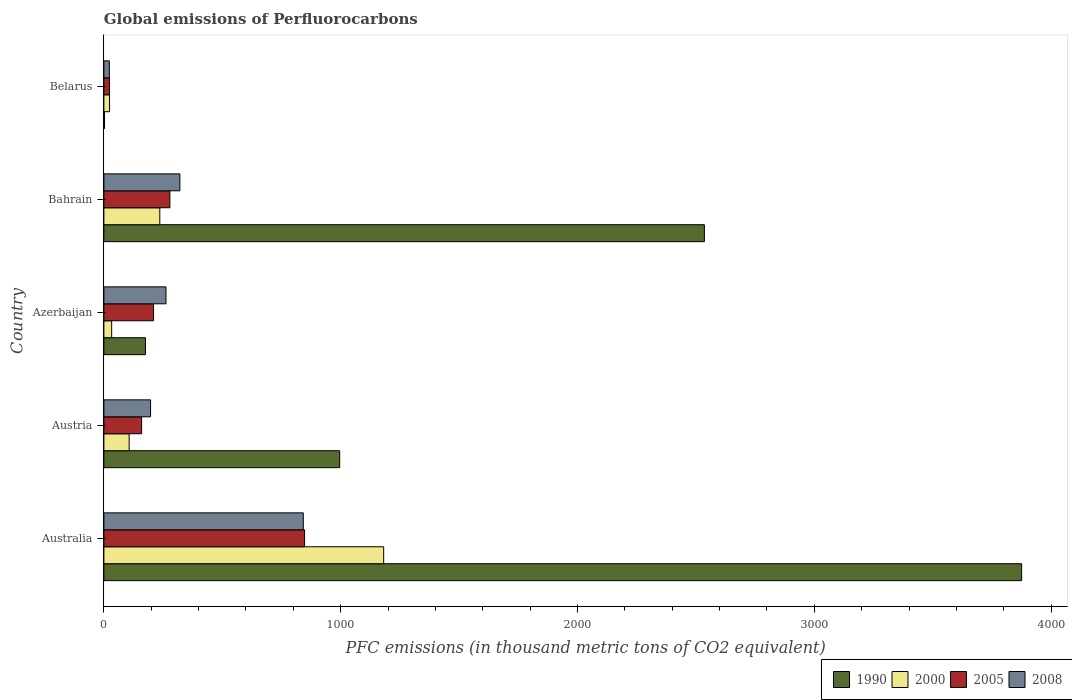Are the number of bars per tick equal to the number of legend labels?
Provide a succinct answer. Yes. In how many cases, is the number of bars for a given country not equal to the number of legend labels?
Make the answer very short. 0. What is the global emissions of Perfluorocarbons in 2005 in Austria?
Ensure brevity in your answer.  159.3. Across all countries, what is the maximum global emissions of Perfluorocarbons in 2008?
Your answer should be very brief. 842. Across all countries, what is the minimum global emissions of Perfluorocarbons in 2005?
Ensure brevity in your answer.  23.4. In which country was the global emissions of Perfluorocarbons in 2005 maximum?
Your answer should be very brief. Australia. In which country was the global emissions of Perfluorocarbons in 1990 minimum?
Keep it short and to the point. Belarus. What is the total global emissions of Perfluorocarbons in 2000 in the graph?
Offer a terse response. 1580.9. What is the difference between the global emissions of Perfluorocarbons in 2005 in Austria and that in Bahrain?
Offer a terse response. -119.3. What is the difference between the global emissions of Perfluorocarbons in 1990 in Bahrain and the global emissions of Perfluorocarbons in 2008 in Azerbaijan?
Make the answer very short. 2273.5. What is the average global emissions of Perfluorocarbons in 1990 per country?
Offer a very short reply. 1516.96. What is the difference between the global emissions of Perfluorocarbons in 2008 and global emissions of Perfluorocarbons in 2005 in Azerbaijan?
Provide a succinct answer. 52.5. What is the ratio of the global emissions of Perfluorocarbons in 2008 in Austria to that in Bahrain?
Your answer should be compact. 0.61. Is the difference between the global emissions of Perfluorocarbons in 2008 in Austria and Bahrain greater than the difference between the global emissions of Perfluorocarbons in 2005 in Austria and Bahrain?
Give a very brief answer. No. What is the difference between the highest and the second highest global emissions of Perfluorocarbons in 2008?
Make the answer very short. 521.1. What is the difference between the highest and the lowest global emissions of Perfluorocarbons in 2000?
Offer a very short reply. 1157.5. In how many countries, is the global emissions of Perfluorocarbons in 2005 greater than the average global emissions of Perfluorocarbons in 2005 taken over all countries?
Keep it short and to the point. 1. Is the sum of the global emissions of Perfluorocarbons in 1990 in Austria and Belarus greater than the maximum global emissions of Perfluorocarbons in 2005 across all countries?
Offer a terse response. Yes. Is it the case that in every country, the sum of the global emissions of Perfluorocarbons in 2008 and global emissions of Perfluorocarbons in 1990 is greater than the sum of global emissions of Perfluorocarbons in 2000 and global emissions of Perfluorocarbons in 2005?
Provide a short and direct response. No. What does the 2nd bar from the bottom in Austria represents?
Make the answer very short. 2000. What is the difference between two consecutive major ticks on the X-axis?
Make the answer very short. 1000. Where does the legend appear in the graph?
Ensure brevity in your answer.  Bottom right. How many legend labels are there?
Your answer should be very brief. 4. How are the legend labels stacked?
Keep it short and to the point. Horizontal. What is the title of the graph?
Offer a terse response. Global emissions of Perfluorocarbons. What is the label or title of the X-axis?
Your answer should be compact. PFC emissions (in thousand metric tons of CO2 equivalent). What is the label or title of the Y-axis?
Offer a very short reply. Country. What is the PFC emissions (in thousand metric tons of CO2 equivalent) of 1990 in Australia?
Give a very brief answer. 3875.2. What is the PFC emissions (in thousand metric tons of CO2 equivalent) in 2000 in Australia?
Offer a very short reply. 1181.4. What is the PFC emissions (in thousand metric tons of CO2 equivalent) of 2005 in Australia?
Your answer should be compact. 847.4. What is the PFC emissions (in thousand metric tons of CO2 equivalent) in 2008 in Australia?
Ensure brevity in your answer.  842. What is the PFC emissions (in thousand metric tons of CO2 equivalent) in 1990 in Austria?
Keep it short and to the point. 995.7. What is the PFC emissions (in thousand metric tons of CO2 equivalent) of 2000 in Austria?
Provide a short and direct response. 106.7. What is the PFC emissions (in thousand metric tons of CO2 equivalent) in 2005 in Austria?
Keep it short and to the point. 159.3. What is the PFC emissions (in thousand metric tons of CO2 equivalent) of 2008 in Austria?
Your response must be concise. 197.1. What is the PFC emissions (in thousand metric tons of CO2 equivalent) of 1990 in Azerbaijan?
Provide a succinct answer. 175.6. What is the PFC emissions (in thousand metric tons of CO2 equivalent) of 2000 in Azerbaijan?
Make the answer very short. 32.8. What is the PFC emissions (in thousand metric tons of CO2 equivalent) in 2005 in Azerbaijan?
Offer a terse response. 209.7. What is the PFC emissions (in thousand metric tons of CO2 equivalent) of 2008 in Azerbaijan?
Your answer should be compact. 262.2. What is the PFC emissions (in thousand metric tons of CO2 equivalent) of 1990 in Bahrain?
Your answer should be very brief. 2535.7. What is the PFC emissions (in thousand metric tons of CO2 equivalent) in 2000 in Bahrain?
Provide a short and direct response. 236.1. What is the PFC emissions (in thousand metric tons of CO2 equivalent) of 2005 in Bahrain?
Give a very brief answer. 278.6. What is the PFC emissions (in thousand metric tons of CO2 equivalent) of 2008 in Bahrain?
Keep it short and to the point. 320.9. What is the PFC emissions (in thousand metric tons of CO2 equivalent) in 1990 in Belarus?
Your answer should be very brief. 2.6. What is the PFC emissions (in thousand metric tons of CO2 equivalent) in 2000 in Belarus?
Your answer should be compact. 23.9. What is the PFC emissions (in thousand metric tons of CO2 equivalent) of 2005 in Belarus?
Your answer should be compact. 23.4. What is the PFC emissions (in thousand metric tons of CO2 equivalent) of 2008 in Belarus?
Make the answer very short. 23.1. Across all countries, what is the maximum PFC emissions (in thousand metric tons of CO2 equivalent) in 1990?
Your response must be concise. 3875.2. Across all countries, what is the maximum PFC emissions (in thousand metric tons of CO2 equivalent) in 2000?
Ensure brevity in your answer.  1181.4. Across all countries, what is the maximum PFC emissions (in thousand metric tons of CO2 equivalent) in 2005?
Provide a short and direct response. 847.4. Across all countries, what is the maximum PFC emissions (in thousand metric tons of CO2 equivalent) of 2008?
Ensure brevity in your answer.  842. Across all countries, what is the minimum PFC emissions (in thousand metric tons of CO2 equivalent) in 2000?
Ensure brevity in your answer.  23.9. Across all countries, what is the minimum PFC emissions (in thousand metric tons of CO2 equivalent) in 2005?
Your response must be concise. 23.4. Across all countries, what is the minimum PFC emissions (in thousand metric tons of CO2 equivalent) of 2008?
Ensure brevity in your answer.  23.1. What is the total PFC emissions (in thousand metric tons of CO2 equivalent) of 1990 in the graph?
Ensure brevity in your answer.  7584.8. What is the total PFC emissions (in thousand metric tons of CO2 equivalent) in 2000 in the graph?
Offer a terse response. 1580.9. What is the total PFC emissions (in thousand metric tons of CO2 equivalent) of 2005 in the graph?
Provide a short and direct response. 1518.4. What is the total PFC emissions (in thousand metric tons of CO2 equivalent) of 2008 in the graph?
Ensure brevity in your answer.  1645.3. What is the difference between the PFC emissions (in thousand metric tons of CO2 equivalent) in 1990 in Australia and that in Austria?
Your answer should be very brief. 2879.5. What is the difference between the PFC emissions (in thousand metric tons of CO2 equivalent) in 2000 in Australia and that in Austria?
Your answer should be compact. 1074.7. What is the difference between the PFC emissions (in thousand metric tons of CO2 equivalent) in 2005 in Australia and that in Austria?
Provide a short and direct response. 688.1. What is the difference between the PFC emissions (in thousand metric tons of CO2 equivalent) of 2008 in Australia and that in Austria?
Provide a short and direct response. 644.9. What is the difference between the PFC emissions (in thousand metric tons of CO2 equivalent) in 1990 in Australia and that in Azerbaijan?
Your answer should be very brief. 3699.6. What is the difference between the PFC emissions (in thousand metric tons of CO2 equivalent) of 2000 in Australia and that in Azerbaijan?
Provide a short and direct response. 1148.6. What is the difference between the PFC emissions (in thousand metric tons of CO2 equivalent) of 2005 in Australia and that in Azerbaijan?
Your answer should be compact. 637.7. What is the difference between the PFC emissions (in thousand metric tons of CO2 equivalent) in 2008 in Australia and that in Azerbaijan?
Ensure brevity in your answer.  579.8. What is the difference between the PFC emissions (in thousand metric tons of CO2 equivalent) in 1990 in Australia and that in Bahrain?
Give a very brief answer. 1339.5. What is the difference between the PFC emissions (in thousand metric tons of CO2 equivalent) of 2000 in Australia and that in Bahrain?
Provide a short and direct response. 945.3. What is the difference between the PFC emissions (in thousand metric tons of CO2 equivalent) of 2005 in Australia and that in Bahrain?
Provide a short and direct response. 568.8. What is the difference between the PFC emissions (in thousand metric tons of CO2 equivalent) in 2008 in Australia and that in Bahrain?
Your response must be concise. 521.1. What is the difference between the PFC emissions (in thousand metric tons of CO2 equivalent) of 1990 in Australia and that in Belarus?
Your answer should be compact. 3872.6. What is the difference between the PFC emissions (in thousand metric tons of CO2 equivalent) of 2000 in Australia and that in Belarus?
Offer a very short reply. 1157.5. What is the difference between the PFC emissions (in thousand metric tons of CO2 equivalent) of 2005 in Australia and that in Belarus?
Provide a succinct answer. 824. What is the difference between the PFC emissions (in thousand metric tons of CO2 equivalent) in 2008 in Australia and that in Belarus?
Give a very brief answer. 818.9. What is the difference between the PFC emissions (in thousand metric tons of CO2 equivalent) in 1990 in Austria and that in Azerbaijan?
Your answer should be very brief. 820.1. What is the difference between the PFC emissions (in thousand metric tons of CO2 equivalent) in 2000 in Austria and that in Azerbaijan?
Offer a very short reply. 73.9. What is the difference between the PFC emissions (in thousand metric tons of CO2 equivalent) in 2005 in Austria and that in Azerbaijan?
Offer a terse response. -50.4. What is the difference between the PFC emissions (in thousand metric tons of CO2 equivalent) in 2008 in Austria and that in Azerbaijan?
Your answer should be very brief. -65.1. What is the difference between the PFC emissions (in thousand metric tons of CO2 equivalent) in 1990 in Austria and that in Bahrain?
Provide a short and direct response. -1540. What is the difference between the PFC emissions (in thousand metric tons of CO2 equivalent) in 2000 in Austria and that in Bahrain?
Your response must be concise. -129.4. What is the difference between the PFC emissions (in thousand metric tons of CO2 equivalent) in 2005 in Austria and that in Bahrain?
Your response must be concise. -119.3. What is the difference between the PFC emissions (in thousand metric tons of CO2 equivalent) of 2008 in Austria and that in Bahrain?
Provide a succinct answer. -123.8. What is the difference between the PFC emissions (in thousand metric tons of CO2 equivalent) of 1990 in Austria and that in Belarus?
Offer a very short reply. 993.1. What is the difference between the PFC emissions (in thousand metric tons of CO2 equivalent) in 2000 in Austria and that in Belarus?
Provide a short and direct response. 82.8. What is the difference between the PFC emissions (in thousand metric tons of CO2 equivalent) in 2005 in Austria and that in Belarus?
Your answer should be very brief. 135.9. What is the difference between the PFC emissions (in thousand metric tons of CO2 equivalent) in 2008 in Austria and that in Belarus?
Provide a short and direct response. 174. What is the difference between the PFC emissions (in thousand metric tons of CO2 equivalent) in 1990 in Azerbaijan and that in Bahrain?
Offer a very short reply. -2360.1. What is the difference between the PFC emissions (in thousand metric tons of CO2 equivalent) of 2000 in Azerbaijan and that in Bahrain?
Provide a succinct answer. -203.3. What is the difference between the PFC emissions (in thousand metric tons of CO2 equivalent) in 2005 in Azerbaijan and that in Bahrain?
Your answer should be compact. -68.9. What is the difference between the PFC emissions (in thousand metric tons of CO2 equivalent) in 2008 in Azerbaijan and that in Bahrain?
Make the answer very short. -58.7. What is the difference between the PFC emissions (in thousand metric tons of CO2 equivalent) in 1990 in Azerbaijan and that in Belarus?
Your answer should be very brief. 173. What is the difference between the PFC emissions (in thousand metric tons of CO2 equivalent) of 2000 in Azerbaijan and that in Belarus?
Provide a short and direct response. 8.9. What is the difference between the PFC emissions (in thousand metric tons of CO2 equivalent) of 2005 in Azerbaijan and that in Belarus?
Ensure brevity in your answer.  186.3. What is the difference between the PFC emissions (in thousand metric tons of CO2 equivalent) in 2008 in Azerbaijan and that in Belarus?
Keep it short and to the point. 239.1. What is the difference between the PFC emissions (in thousand metric tons of CO2 equivalent) of 1990 in Bahrain and that in Belarus?
Keep it short and to the point. 2533.1. What is the difference between the PFC emissions (in thousand metric tons of CO2 equivalent) in 2000 in Bahrain and that in Belarus?
Keep it short and to the point. 212.2. What is the difference between the PFC emissions (in thousand metric tons of CO2 equivalent) in 2005 in Bahrain and that in Belarus?
Offer a very short reply. 255.2. What is the difference between the PFC emissions (in thousand metric tons of CO2 equivalent) in 2008 in Bahrain and that in Belarus?
Provide a succinct answer. 297.8. What is the difference between the PFC emissions (in thousand metric tons of CO2 equivalent) of 1990 in Australia and the PFC emissions (in thousand metric tons of CO2 equivalent) of 2000 in Austria?
Make the answer very short. 3768.5. What is the difference between the PFC emissions (in thousand metric tons of CO2 equivalent) of 1990 in Australia and the PFC emissions (in thousand metric tons of CO2 equivalent) of 2005 in Austria?
Provide a succinct answer. 3715.9. What is the difference between the PFC emissions (in thousand metric tons of CO2 equivalent) in 1990 in Australia and the PFC emissions (in thousand metric tons of CO2 equivalent) in 2008 in Austria?
Make the answer very short. 3678.1. What is the difference between the PFC emissions (in thousand metric tons of CO2 equivalent) of 2000 in Australia and the PFC emissions (in thousand metric tons of CO2 equivalent) of 2005 in Austria?
Give a very brief answer. 1022.1. What is the difference between the PFC emissions (in thousand metric tons of CO2 equivalent) of 2000 in Australia and the PFC emissions (in thousand metric tons of CO2 equivalent) of 2008 in Austria?
Offer a very short reply. 984.3. What is the difference between the PFC emissions (in thousand metric tons of CO2 equivalent) in 2005 in Australia and the PFC emissions (in thousand metric tons of CO2 equivalent) in 2008 in Austria?
Provide a short and direct response. 650.3. What is the difference between the PFC emissions (in thousand metric tons of CO2 equivalent) in 1990 in Australia and the PFC emissions (in thousand metric tons of CO2 equivalent) in 2000 in Azerbaijan?
Give a very brief answer. 3842.4. What is the difference between the PFC emissions (in thousand metric tons of CO2 equivalent) in 1990 in Australia and the PFC emissions (in thousand metric tons of CO2 equivalent) in 2005 in Azerbaijan?
Ensure brevity in your answer.  3665.5. What is the difference between the PFC emissions (in thousand metric tons of CO2 equivalent) of 1990 in Australia and the PFC emissions (in thousand metric tons of CO2 equivalent) of 2008 in Azerbaijan?
Offer a very short reply. 3613. What is the difference between the PFC emissions (in thousand metric tons of CO2 equivalent) in 2000 in Australia and the PFC emissions (in thousand metric tons of CO2 equivalent) in 2005 in Azerbaijan?
Provide a short and direct response. 971.7. What is the difference between the PFC emissions (in thousand metric tons of CO2 equivalent) of 2000 in Australia and the PFC emissions (in thousand metric tons of CO2 equivalent) of 2008 in Azerbaijan?
Offer a terse response. 919.2. What is the difference between the PFC emissions (in thousand metric tons of CO2 equivalent) of 2005 in Australia and the PFC emissions (in thousand metric tons of CO2 equivalent) of 2008 in Azerbaijan?
Provide a short and direct response. 585.2. What is the difference between the PFC emissions (in thousand metric tons of CO2 equivalent) of 1990 in Australia and the PFC emissions (in thousand metric tons of CO2 equivalent) of 2000 in Bahrain?
Offer a very short reply. 3639.1. What is the difference between the PFC emissions (in thousand metric tons of CO2 equivalent) in 1990 in Australia and the PFC emissions (in thousand metric tons of CO2 equivalent) in 2005 in Bahrain?
Provide a short and direct response. 3596.6. What is the difference between the PFC emissions (in thousand metric tons of CO2 equivalent) in 1990 in Australia and the PFC emissions (in thousand metric tons of CO2 equivalent) in 2008 in Bahrain?
Provide a short and direct response. 3554.3. What is the difference between the PFC emissions (in thousand metric tons of CO2 equivalent) of 2000 in Australia and the PFC emissions (in thousand metric tons of CO2 equivalent) of 2005 in Bahrain?
Give a very brief answer. 902.8. What is the difference between the PFC emissions (in thousand metric tons of CO2 equivalent) in 2000 in Australia and the PFC emissions (in thousand metric tons of CO2 equivalent) in 2008 in Bahrain?
Keep it short and to the point. 860.5. What is the difference between the PFC emissions (in thousand metric tons of CO2 equivalent) in 2005 in Australia and the PFC emissions (in thousand metric tons of CO2 equivalent) in 2008 in Bahrain?
Make the answer very short. 526.5. What is the difference between the PFC emissions (in thousand metric tons of CO2 equivalent) of 1990 in Australia and the PFC emissions (in thousand metric tons of CO2 equivalent) of 2000 in Belarus?
Offer a terse response. 3851.3. What is the difference between the PFC emissions (in thousand metric tons of CO2 equivalent) in 1990 in Australia and the PFC emissions (in thousand metric tons of CO2 equivalent) in 2005 in Belarus?
Your answer should be compact. 3851.8. What is the difference between the PFC emissions (in thousand metric tons of CO2 equivalent) of 1990 in Australia and the PFC emissions (in thousand metric tons of CO2 equivalent) of 2008 in Belarus?
Offer a terse response. 3852.1. What is the difference between the PFC emissions (in thousand metric tons of CO2 equivalent) in 2000 in Australia and the PFC emissions (in thousand metric tons of CO2 equivalent) in 2005 in Belarus?
Your answer should be very brief. 1158. What is the difference between the PFC emissions (in thousand metric tons of CO2 equivalent) in 2000 in Australia and the PFC emissions (in thousand metric tons of CO2 equivalent) in 2008 in Belarus?
Offer a terse response. 1158.3. What is the difference between the PFC emissions (in thousand metric tons of CO2 equivalent) of 2005 in Australia and the PFC emissions (in thousand metric tons of CO2 equivalent) of 2008 in Belarus?
Give a very brief answer. 824.3. What is the difference between the PFC emissions (in thousand metric tons of CO2 equivalent) of 1990 in Austria and the PFC emissions (in thousand metric tons of CO2 equivalent) of 2000 in Azerbaijan?
Provide a succinct answer. 962.9. What is the difference between the PFC emissions (in thousand metric tons of CO2 equivalent) in 1990 in Austria and the PFC emissions (in thousand metric tons of CO2 equivalent) in 2005 in Azerbaijan?
Make the answer very short. 786. What is the difference between the PFC emissions (in thousand metric tons of CO2 equivalent) of 1990 in Austria and the PFC emissions (in thousand metric tons of CO2 equivalent) of 2008 in Azerbaijan?
Make the answer very short. 733.5. What is the difference between the PFC emissions (in thousand metric tons of CO2 equivalent) of 2000 in Austria and the PFC emissions (in thousand metric tons of CO2 equivalent) of 2005 in Azerbaijan?
Ensure brevity in your answer.  -103. What is the difference between the PFC emissions (in thousand metric tons of CO2 equivalent) in 2000 in Austria and the PFC emissions (in thousand metric tons of CO2 equivalent) in 2008 in Azerbaijan?
Your answer should be compact. -155.5. What is the difference between the PFC emissions (in thousand metric tons of CO2 equivalent) of 2005 in Austria and the PFC emissions (in thousand metric tons of CO2 equivalent) of 2008 in Azerbaijan?
Your answer should be very brief. -102.9. What is the difference between the PFC emissions (in thousand metric tons of CO2 equivalent) of 1990 in Austria and the PFC emissions (in thousand metric tons of CO2 equivalent) of 2000 in Bahrain?
Ensure brevity in your answer.  759.6. What is the difference between the PFC emissions (in thousand metric tons of CO2 equivalent) of 1990 in Austria and the PFC emissions (in thousand metric tons of CO2 equivalent) of 2005 in Bahrain?
Your answer should be very brief. 717.1. What is the difference between the PFC emissions (in thousand metric tons of CO2 equivalent) of 1990 in Austria and the PFC emissions (in thousand metric tons of CO2 equivalent) of 2008 in Bahrain?
Provide a short and direct response. 674.8. What is the difference between the PFC emissions (in thousand metric tons of CO2 equivalent) in 2000 in Austria and the PFC emissions (in thousand metric tons of CO2 equivalent) in 2005 in Bahrain?
Offer a very short reply. -171.9. What is the difference between the PFC emissions (in thousand metric tons of CO2 equivalent) in 2000 in Austria and the PFC emissions (in thousand metric tons of CO2 equivalent) in 2008 in Bahrain?
Your answer should be very brief. -214.2. What is the difference between the PFC emissions (in thousand metric tons of CO2 equivalent) in 2005 in Austria and the PFC emissions (in thousand metric tons of CO2 equivalent) in 2008 in Bahrain?
Ensure brevity in your answer.  -161.6. What is the difference between the PFC emissions (in thousand metric tons of CO2 equivalent) of 1990 in Austria and the PFC emissions (in thousand metric tons of CO2 equivalent) of 2000 in Belarus?
Keep it short and to the point. 971.8. What is the difference between the PFC emissions (in thousand metric tons of CO2 equivalent) of 1990 in Austria and the PFC emissions (in thousand metric tons of CO2 equivalent) of 2005 in Belarus?
Ensure brevity in your answer.  972.3. What is the difference between the PFC emissions (in thousand metric tons of CO2 equivalent) of 1990 in Austria and the PFC emissions (in thousand metric tons of CO2 equivalent) of 2008 in Belarus?
Your response must be concise. 972.6. What is the difference between the PFC emissions (in thousand metric tons of CO2 equivalent) in 2000 in Austria and the PFC emissions (in thousand metric tons of CO2 equivalent) in 2005 in Belarus?
Offer a terse response. 83.3. What is the difference between the PFC emissions (in thousand metric tons of CO2 equivalent) in 2000 in Austria and the PFC emissions (in thousand metric tons of CO2 equivalent) in 2008 in Belarus?
Offer a very short reply. 83.6. What is the difference between the PFC emissions (in thousand metric tons of CO2 equivalent) of 2005 in Austria and the PFC emissions (in thousand metric tons of CO2 equivalent) of 2008 in Belarus?
Provide a succinct answer. 136.2. What is the difference between the PFC emissions (in thousand metric tons of CO2 equivalent) in 1990 in Azerbaijan and the PFC emissions (in thousand metric tons of CO2 equivalent) in 2000 in Bahrain?
Offer a terse response. -60.5. What is the difference between the PFC emissions (in thousand metric tons of CO2 equivalent) of 1990 in Azerbaijan and the PFC emissions (in thousand metric tons of CO2 equivalent) of 2005 in Bahrain?
Ensure brevity in your answer.  -103. What is the difference between the PFC emissions (in thousand metric tons of CO2 equivalent) in 1990 in Azerbaijan and the PFC emissions (in thousand metric tons of CO2 equivalent) in 2008 in Bahrain?
Provide a short and direct response. -145.3. What is the difference between the PFC emissions (in thousand metric tons of CO2 equivalent) in 2000 in Azerbaijan and the PFC emissions (in thousand metric tons of CO2 equivalent) in 2005 in Bahrain?
Make the answer very short. -245.8. What is the difference between the PFC emissions (in thousand metric tons of CO2 equivalent) in 2000 in Azerbaijan and the PFC emissions (in thousand metric tons of CO2 equivalent) in 2008 in Bahrain?
Your answer should be very brief. -288.1. What is the difference between the PFC emissions (in thousand metric tons of CO2 equivalent) in 2005 in Azerbaijan and the PFC emissions (in thousand metric tons of CO2 equivalent) in 2008 in Bahrain?
Your answer should be very brief. -111.2. What is the difference between the PFC emissions (in thousand metric tons of CO2 equivalent) of 1990 in Azerbaijan and the PFC emissions (in thousand metric tons of CO2 equivalent) of 2000 in Belarus?
Ensure brevity in your answer.  151.7. What is the difference between the PFC emissions (in thousand metric tons of CO2 equivalent) in 1990 in Azerbaijan and the PFC emissions (in thousand metric tons of CO2 equivalent) in 2005 in Belarus?
Give a very brief answer. 152.2. What is the difference between the PFC emissions (in thousand metric tons of CO2 equivalent) in 1990 in Azerbaijan and the PFC emissions (in thousand metric tons of CO2 equivalent) in 2008 in Belarus?
Make the answer very short. 152.5. What is the difference between the PFC emissions (in thousand metric tons of CO2 equivalent) in 2000 in Azerbaijan and the PFC emissions (in thousand metric tons of CO2 equivalent) in 2005 in Belarus?
Provide a short and direct response. 9.4. What is the difference between the PFC emissions (in thousand metric tons of CO2 equivalent) in 2000 in Azerbaijan and the PFC emissions (in thousand metric tons of CO2 equivalent) in 2008 in Belarus?
Give a very brief answer. 9.7. What is the difference between the PFC emissions (in thousand metric tons of CO2 equivalent) in 2005 in Azerbaijan and the PFC emissions (in thousand metric tons of CO2 equivalent) in 2008 in Belarus?
Make the answer very short. 186.6. What is the difference between the PFC emissions (in thousand metric tons of CO2 equivalent) of 1990 in Bahrain and the PFC emissions (in thousand metric tons of CO2 equivalent) of 2000 in Belarus?
Your response must be concise. 2511.8. What is the difference between the PFC emissions (in thousand metric tons of CO2 equivalent) in 1990 in Bahrain and the PFC emissions (in thousand metric tons of CO2 equivalent) in 2005 in Belarus?
Give a very brief answer. 2512.3. What is the difference between the PFC emissions (in thousand metric tons of CO2 equivalent) in 1990 in Bahrain and the PFC emissions (in thousand metric tons of CO2 equivalent) in 2008 in Belarus?
Ensure brevity in your answer.  2512.6. What is the difference between the PFC emissions (in thousand metric tons of CO2 equivalent) of 2000 in Bahrain and the PFC emissions (in thousand metric tons of CO2 equivalent) of 2005 in Belarus?
Your answer should be compact. 212.7. What is the difference between the PFC emissions (in thousand metric tons of CO2 equivalent) of 2000 in Bahrain and the PFC emissions (in thousand metric tons of CO2 equivalent) of 2008 in Belarus?
Provide a succinct answer. 213. What is the difference between the PFC emissions (in thousand metric tons of CO2 equivalent) of 2005 in Bahrain and the PFC emissions (in thousand metric tons of CO2 equivalent) of 2008 in Belarus?
Provide a short and direct response. 255.5. What is the average PFC emissions (in thousand metric tons of CO2 equivalent) in 1990 per country?
Your answer should be compact. 1516.96. What is the average PFC emissions (in thousand metric tons of CO2 equivalent) of 2000 per country?
Ensure brevity in your answer.  316.18. What is the average PFC emissions (in thousand metric tons of CO2 equivalent) in 2005 per country?
Make the answer very short. 303.68. What is the average PFC emissions (in thousand metric tons of CO2 equivalent) of 2008 per country?
Make the answer very short. 329.06. What is the difference between the PFC emissions (in thousand metric tons of CO2 equivalent) in 1990 and PFC emissions (in thousand metric tons of CO2 equivalent) in 2000 in Australia?
Your answer should be very brief. 2693.8. What is the difference between the PFC emissions (in thousand metric tons of CO2 equivalent) of 1990 and PFC emissions (in thousand metric tons of CO2 equivalent) of 2005 in Australia?
Your answer should be compact. 3027.8. What is the difference between the PFC emissions (in thousand metric tons of CO2 equivalent) of 1990 and PFC emissions (in thousand metric tons of CO2 equivalent) of 2008 in Australia?
Offer a terse response. 3033.2. What is the difference between the PFC emissions (in thousand metric tons of CO2 equivalent) in 2000 and PFC emissions (in thousand metric tons of CO2 equivalent) in 2005 in Australia?
Give a very brief answer. 334. What is the difference between the PFC emissions (in thousand metric tons of CO2 equivalent) of 2000 and PFC emissions (in thousand metric tons of CO2 equivalent) of 2008 in Australia?
Give a very brief answer. 339.4. What is the difference between the PFC emissions (in thousand metric tons of CO2 equivalent) of 2005 and PFC emissions (in thousand metric tons of CO2 equivalent) of 2008 in Australia?
Ensure brevity in your answer.  5.4. What is the difference between the PFC emissions (in thousand metric tons of CO2 equivalent) of 1990 and PFC emissions (in thousand metric tons of CO2 equivalent) of 2000 in Austria?
Make the answer very short. 889. What is the difference between the PFC emissions (in thousand metric tons of CO2 equivalent) in 1990 and PFC emissions (in thousand metric tons of CO2 equivalent) in 2005 in Austria?
Make the answer very short. 836.4. What is the difference between the PFC emissions (in thousand metric tons of CO2 equivalent) of 1990 and PFC emissions (in thousand metric tons of CO2 equivalent) of 2008 in Austria?
Offer a very short reply. 798.6. What is the difference between the PFC emissions (in thousand metric tons of CO2 equivalent) in 2000 and PFC emissions (in thousand metric tons of CO2 equivalent) in 2005 in Austria?
Keep it short and to the point. -52.6. What is the difference between the PFC emissions (in thousand metric tons of CO2 equivalent) of 2000 and PFC emissions (in thousand metric tons of CO2 equivalent) of 2008 in Austria?
Your response must be concise. -90.4. What is the difference between the PFC emissions (in thousand metric tons of CO2 equivalent) of 2005 and PFC emissions (in thousand metric tons of CO2 equivalent) of 2008 in Austria?
Ensure brevity in your answer.  -37.8. What is the difference between the PFC emissions (in thousand metric tons of CO2 equivalent) of 1990 and PFC emissions (in thousand metric tons of CO2 equivalent) of 2000 in Azerbaijan?
Make the answer very short. 142.8. What is the difference between the PFC emissions (in thousand metric tons of CO2 equivalent) of 1990 and PFC emissions (in thousand metric tons of CO2 equivalent) of 2005 in Azerbaijan?
Ensure brevity in your answer.  -34.1. What is the difference between the PFC emissions (in thousand metric tons of CO2 equivalent) of 1990 and PFC emissions (in thousand metric tons of CO2 equivalent) of 2008 in Azerbaijan?
Your answer should be very brief. -86.6. What is the difference between the PFC emissions (in thousand metric tons of CO2 equivalent) in 2000 and PFC emissions (in thousand metric tons of CO2 equivalent) in 2005 in Azerbaijan?
Your response must be concise. -176.9. What is the difference between the PFC emissions (in thousand metric tons of CO2 equivalent) of 2000 and PFC emissions (in thousand metric tons of CO2 equivalent) of 2008 in Azerbaijan?
Give a very brief answer. -229.4. What is the difference between the PFC emissions (in thousand metric tons of CO2 equivalent) in 2005 and PFC emissions (in thousand metric tons of CO2 equivalent) in 2008 in Azerbaijan?
Keep it short and to the point. -52.5. What is the difference between the PFC emissions (in thousand metric tons of CO2 equivalent) of 1990 and PFC emissions (in thousand metric tons of CO2 equivalent) of 2000 in Bahrain?
Provide a short and direct response. 2299.6. What is the difference between the PFC emissions (in thousand metric tons of CO2 equivalent) of 1990 and PFC emissions (in thousand metric tons of CO2 equivalent) of 2005 in Bahrain?
Keep it short and to the point. 2257.1. What is the difference between the PFC emissions (in thousand metric tons of CO2 equivalent) of 1990 and PFC emissions (in thousand metric tons of CO2 equivalent) of 2008 in Bahrain?
Ensure brevity in your answer.  2214.8. What is the difference between the PFC emissions (in thousand metric tons of CO2 equivalent) in 2000 and PFC emissions (in thousand metric tons of CO2 equivalent) in 2005 in Bahrain?
Keep it short and to the point. -42.5. What is the difference between the PFC emissions (in thousand metric tons of CO2 equivalent) of 2000 and PFC emissions (in thousand metric tons of CO2 equivalent) of 2008 in Bahrain?
Offer a very short reply. -84.8. What is the difference between the PFC emissions (in thousand metric tons of CO2 equivalent) of 2005 and PFC emissions (in thousand metric tons of CO2 equivalent) of 2008 in Bahrain?
Give a very brief answer. -42.3. What is the difference between the PFC emissions (in thousand metric tons of CO2 equivalent) of 1990 and PFC emissions (in thousand metric tons of CO2 equivalent) of 2000 in Belarus?
Your answer should be compact. -21.3. What is the difference between the PFC emissions (in thousand metric tons of CO2 equivalent) in 1990 and PFC emissions (in thousand metric tons of CO2 equivalent) in 2005 in Belarus?
Ensure brevity in your answer.  -20.8. What is the difference between the PFC emissions (in thousand metric tons of CO2 equivalent) in 1990 and PFC emissions (in thousand metric tons of CO2 equivalent) in 2008 in Belarus?
Keep it short and to the point. -20.5. What is the difference between the PFC emissions (in thousand metric tons of CO2 equivalent) of 2000 and PFC emissions (in thousand metric tons of CO2 equivalent) of 2008 in Belarus?
Offer a very short reply. 0.8. What is the difference between the PFC emissions (in thousand metric tons of CO2 equivalent) of 2005 and PFC emissions (in thousand metric tons of CO2 equivalent) of 2008 in Belarus?
Your answer should be compact. 0.3. What is the ratio of the PFC emissions (in thousand metric tons of CO2 equivalent) in 1990 in Australia to that in Austria?
Give a very brief answer. 3.89. What is the ratio of the PFC emissions (in thousand metric tons of CO2 equivalent) in 2000 in Australia to that in Austria?
Give a very brief answer. 11.07. What is the ratio of the PFC emissions (in thousand metric tons of CO2 equivalent) in 2005 in Australia to that in Austria?
Offer a terse response. 5.32. What is the ratio of the PFC emissions (in thousand metric tons of CO2 equivalent) in 2008 in Australia to that in Austria?
Offer a terse response. 4.27. What is the ratio of the PFC emissions (in thousand metric tons of CO2 equivalent) in 1990 in Australia to that in Azerbaijan?
Your answer should be very brief. 22.07. What is the ratio of the PFC emissions (in thousand metric tons of CO2 equivalent) in 2000 in Australia to that in Azerbaijan?
Provide a short and direct response. 36.02. What is the ratio of the PFC emissions (in thousand metric tons of CO2 equivalent) in 2005 in Australia to that in Azerbaijan?
Your answer should be compact. 4.04. What is the ratio of the PFC emissions (in thousand metric tons of CO2 equivalent) of 2008 in Australia to that in Azerbaijan?
Give a very brief answer. 3.21. What is the ratio of the PFC emissions (in thousand metric tons of CO2 equivalent) of 1990 in Australia to that in Bahrain?
Provide a short and direct response. 1.53. What is the ratio of the PFC emissions (in thousand metric tons of CO2 equivalent) in 2000 in Australia to that in Bahrain?
Your answer should be compact. 5. What is the ratio of the PFC emissions (in thousand metric tons of CO2 equivalent) of 2005 in Australia to that in Bahrain?
Your answer should be compact. 3.04. What is the ratio of the PFC emissions (in thousand metric tons of CO2 equivalent) of 2008 in Australia to that in Bahrain?
Ensure brevity in your answer.  2.62. What is the ratio of the PFC emissions (in thousand metric tons of CO2 equivalent) in 1990 in Australia to that in Belarus?
Your answer should be very brief. 1490.46. What is the ratio of the PFC emissions (in thousand metric tons of CO2 equivalent) of 2000 in Australia to that in Belarus?
Your answer should be compact. 49.43. What is the ratio of the PFC emissions (in thousand metric tons of CO2 equivalent) in 2005 in Australia to that in Belarus?
Make the answer very short. 36.21. What is the ratio of the PFC emissions (in thousand metric tons of CO2 equivalent) of 2008 in Australia to that in Belarus?
Your response must be concise. 36.45. What is the ratio of the PFC emissions (in thousand metric tons of CO2 equivalent) in 1990 in Austria to that in Azerbaijan?
Your answer should be compact. 5.67. What is the ratio of the PFC emissions (in thousand metric tons of CO2 equivalent) in 2000 in Austria to that in Azerbaijan?
Keep it short and to the point. 3.25. What is the ratio of the PFC emissions (in thousand metric tons of CO2 equivalent) in 2005 in Austria to that in Azerbaijan?
Your response must be concise. 0.76. What is the ratio of the PFC emissions (in thousand metric tons of CO2 equivalent) of 2008 in Austria to that in Azerbaijan?
Provide a succinct answer. 0.75. What is the ratio of the PFC emissions (in thousand metric tons of CO2 equivalent) in 1990 in Austria to that in Bahrain?
Provide a succinct answer. 0.39. What is the ratio of the PFC emissions (in thousand metric tons of CO2 equivalent) of 2000 in Austria to that in Bahrain?
Provide a short and direct response. 0.45. What is the ratio of the PFC emissions (in thousand metric tons of CO2 equivalent) in 2005 in Austria to that in Bahrain?
Your response must be concise. 0.57. What is the ratio of the PFC emissions (in thousand metric tons of CO2 equivalent) in 2008 in Austria to that in Bahrain?
Keep it short and to the point. 0.61. What is the ratio of the PFC emissions (in thousand metric tons of CO2 equivalent) in 1990 in Austria to that in Belarus?
Provide a succinct answer. 382.96. What is the ratio of the PFC emissions (in thousand metric tons of CO2 equivalent) in 2000 in Austria to that in Belarus?
Provide a succinct answer. 4.46. What is the ratio of the PFC emissions (in thousand metric tons of CO2 equivalent) of 2005 in Austria to that in Belarus?
Provide a short and direct response. 6.81. What is the ratio of the PFC emissions (in thousand metric tons of CO2 equivalent) of 2008 in Austria to that in Belarus?
Give a very brief answer. 8.53. What is the ratio of the PFC emissions (in thousand metric tons of CO2 equivalent) in 1990 in Azerbaijan to that in Bahrain?
Keep it short and to the point. 0.07. What is the ratio of the PFC emissions (in thousand metric tons of CO2 equivalent) of 2000 in Azerbaijan to that in Bahrain?
Offer a terse response. 0.14. What is the ratio of the PFC emissions (in thousand metric tons of CO2 equivalent) in 2005 in Azerbaijan to that in Bahrain?
Your response must be concise. 0.75. What is the ratio of the PFC emissions (in thousand metric tons of CO2 equivalent) of 2008 in Azerbaijan to that in Bahrain?
Your response must be concise. 0.82. What is the ratio of the PFC emissions (in thousand metric tons of CO2 equivalent) in 1990 in Azerbaijan to that in Belarus?
Your answer should be compact. 67.54. What is the ratio of the PFC emissions (in thousand metric tons of CO2 equivalent) in 2000 in Azerbaijan to that in Belarus?
Provide a short and direct response. 1.37. What is the ratio of the PFC emissions (in thousand metric tons of CO2 equivalent) in 2005 in Azerbaijan to that in Belarus?
Your response must be concise. 8.96. What is the ratio of the PFC emissions (in thousand metric tons of CO2 equivalent) in 2008 in Azerbaijan to that in Belarus?
Give a very brief answer. 11.35. What is the ratio of the PFC emissions (in thousand metric tons of CO2 equivalent) of 1990 in Bahrain to that in Belarus?
Provide a short and direct response. 975.27. What is the ratio of the PFC emissions (in thousand metric tons of CO2 equivalent) of 2000 in Bahrain to that in Belarus?
Make the answer very short. 9.88. What is the ratio of the PFC emissions (in thousand metric tons of CO2 equivalent) of 2005 in Bahrain to that in Belarus?
Offer a very short reply. 11.91. What is the ratio of the PFC emissions (in thousand metric tons of CO2 equivalent) in 2008 in Bahrain to that in Belarus?
Make the answer very short. 13.89. What is the difference between the highest and the second highest PFC emissions (in thousand metric tons of CO2 equivalent) of 1990?
Ensure brevity in your answer.  1339.5. What is the difference between the highest and the second highest PFC emissions (in thousand metric tons of CO2 equivalent) in 2000?
Make the answer very short. 945.3. What is the difference between the highest and the second highest PFC emissions (in thousand metric tons of CO2 equivalent) of 2005?
Provide a short and direct response. 568.8. What is the difference between the highest and the second highest PFC emissions (in thousand metric tons of CO2 equivalent) in 2008?
Ensure brevity in your answer.  521.1. What is the difference between the highest and the lowest PFC emissions (in thousand metric tons of CO2 equivalent) in 1990?
Make the answer very short. 3872.6. What is the difference between the highest and the lowest PFC emissions (in thousand metric tons of CO2 equivalent) of 2000?
Keep it short and to the point. 1157.5. What is the difference between the highest and the lowest PFC emissions (in thousand metric tons of CO2 equivalent) in 2005?
Your answer should be compact. 824. What is the difference between the highest and the lowest PFC emissions (in thousand metric tons of CO2 equivalent) in 2008?
Provide a short and direct response. 818.9. 